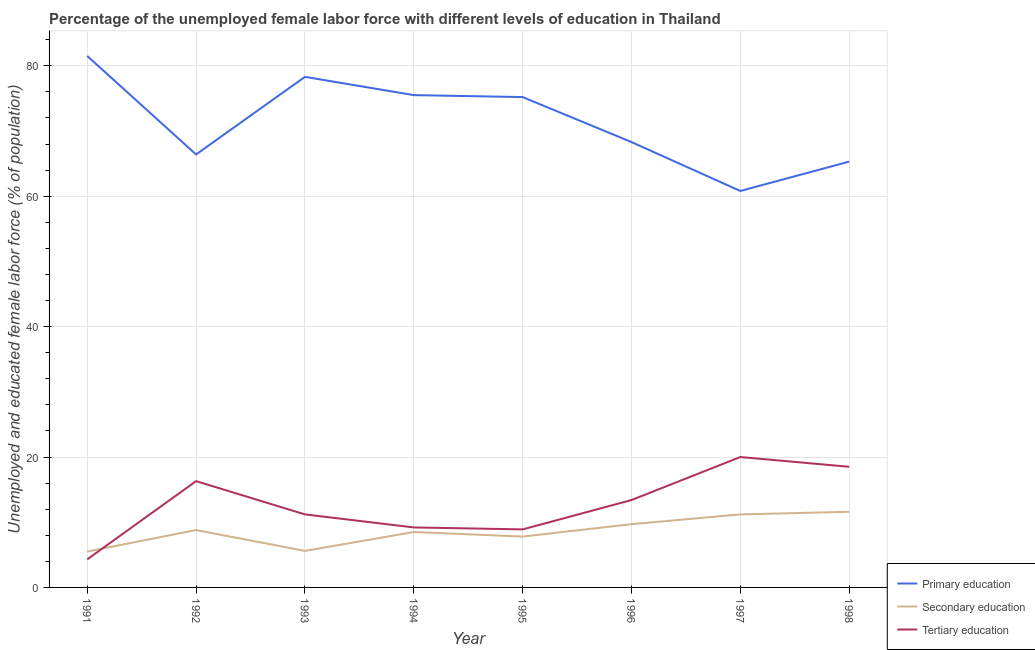How many different coloured lines are there?
Your answer should be very brief. 3. What is the percentage of female labor force who received secondary education in 1992?
Provide a succinct answer. 8.8. Across all years, what is the maximum percentage of female labor force who received secondary education?
Your answer should be very brief. 11.6. Across all years, what is the minimum percentage of female labor force who received secondary education?
Give a very brief answer. 5.5. In which year was the percentage of female labor force who received tertiary education minimum?
Offer a terse response. 1991. What is the total percentage of female labor force who received tertiary education in the graph?
Your answer should be compact. 101.8. What is the difference between the percentage of female labor force who received tertiary education in 1995 and that in 1996?
Ensure brevity in your answer.  -4.5. What is the difference between the percentage of female labor force who received secondary education in 1996 and the percentage of female labor force who received tertiary education in 1993?
Your answer should be compact. -1.5. What is the average percentage of female labor force who received secondary education per year?
Offer a terse response. 8.59. In the year 1997, what is the difference between the percentage of female labor force who received primary education and percentage of female labor force who received tertiary education?
Offer a terse response. 40.8. What is the ratio of the percentage of female labor force who received primary education in 1992 to that in 1998?
Your answer should be very brief. 1.02. Is the difference between the percentage of female labor force who received secondary education in 1991 and 1996 greater than the difference between the percentage of female labor force who received tertiary education in 1991 and 1996?
Your answer should be compact. Yes. What is the difference between the highest and the second highest percentage of female labor force who received primary education?
Make the answer very short. 3.2. What is the difference between the highest and the lowest percentage of female labor force who received primary education?
Offer a terse response. 20.7. In how many years, is the percentage of female labor force who received secondary education greater than the average percentage of female labor force who received secondary education taken over all years?
Keep it short and to the point. 4. Is the sum of the percentage of female labor force who received primary education in 1996 and 1997 greater than the maximum percentage of female labor force who received tertiary education across all years?
Provide a succinct answer. Yes. How many lines are there?
Make the answer very short. 3. What is the difference between two consecutive major ticks on the Y-axis?
Offer a very short reply. 20. Does the graph contain any zero values?
Provide a short and direct response. No. Does the graph contain grids?
Your answer should be very brief. Yes. What is the title of the graph?
Offer a terse response. Percentage of the unemployed female labor force with different levels of education in Thailand. What is the label or title of the X-axis?
Keep it short and to the point. Year. What is the label or title of the Y-axis?
Offer a very short reply. Unemployed and educated female labor force (% of population). What is the Unemployed and educated female labor force (% of population) in Primary education in 1991?
Offer a very short reply. 81.5. What is the Unemployed and educated female labor force (% of population) in Tertiary education in 1991?
Your answer should be very brief. 4.3. What is the Unemployed and educated female labor force (% of population) in Primary education in 1992?
Your answer should be compact. 66.4. What is the Unemployed and educated female labor force (% of population) in Secondary education in 1992?
Provide a short and direct response. 8.8. What is the Unemployed and educated female labor force (% of population) in Tertiary education in 1992?
Your response must be concise. 16.3. What is the Unemployed and educated female labor force (% of population) of Primary education in 1993?
Your answer should be very brief. 78.3. What is the Unemployed and educated female labor force (% of population) of Secondary education in 1993?
Your response must be concise. 5.6. What is the Unemployed and educated female labor force (% of population) in Tertiary education in 1993?
Ensure brevity in your answer.  11.2. What is the Unemployed and educated female labor force (% of population) of Primary education in 1994?
Your answer should be compact. 75.5. What is the Unemployed and educated female labor force (% of population) in Tertiary education in 1994?
Make the answer very short. 9.2. What is the Unemployed and educated female labor force (% of population) in Primary education in 1995?
Offer a terse response. 75.2. What is the Unemployed and educated female labor force (% of population) of Secondary education in 1995?
Provide a succinct answer. 7.8. What is the Unemployed and educated female labor force (% of population) of Tertiary education in 1995?
Your response must be concise. 8.9. What is the Unemployed and educated female labor force (% of population) of Primary education in 1996?
Offer a terse response. 68.3. What is the Unemployed and educated female labor force (% of population) of Secondary education in 1996?
Provide a short and direct response. 9.7. What is the Unemployed and educated female labor force (% of population) of Tertiary education in 1996?
Your response must be concise. 13.4. What is the Unemployed and educated female labor force (% of population) of Primary education in 1997?
Give a very brief answer. 60.8. What is the Unemployed and educated female labor force (% of population) in Secondary education in 1997?
Provide a succinct answer. 11.2. What is the Unemployed and educated female labor force (% of population) in Tertiary education in 1997?
Your answer should be compact. 20. What is the Unemployed and educated female labor force (% of population) of Primary education in 1998?
Give a very brief answer. 65.3. What is the Unemployed and educated female labor force (% of population) in Secondary education in 1998?
Ensure brevity in your answer.  11.6. Across all years, what is the maximum Unemployed and educated female labor force (% of population) of Primary education?
Offer a terse response. 81.5. Across all years, what is the maximum Unemployed and educated female labor force (% of population) in Secondary education?
Ensure brevity in your answer.  11.6. Across all years, what is the minimum Unemployed and educated female labor force (% of population) of Primary education?
Your response must be concise. 60.8. Across all years, what is the minimum Unemployed and educated female labor force (% of population) of Tertiary education?
Your answer should be very brief. 4.3. What is the total Unemployed and educated female labor force (% of population) of Primary education in the graph?
Ensure brevity in your answer.  571.3. What is the total Unemployed and educated female labor force (% of population) in Secondary education in the graph?
Offer a terse response. 68.7. What is the total Unemployed and educated female labor force (% of population) in Tertiary education in the graph?
Give a very brief answer. 101.8. What is the difference between the Unemployed and educated female labor force (% of population) in Primary education in 1991 and that in 1992?
Keep it short and to the point. 15.1. What is the difference between the Unemployed and educated female labor force (% of population) of Tertiary education in 1991 and that in 1992?
Keep it short and to the point. -12. What is the difference between the Unemployed and educated female labor force (% of population) of Secondary education in 1991 and that in 1993?
Give a very brief answer. -0.1. What is the difference between the Unemployed and educated female labor force (% of population) in Tertiary education in 1991 and that in 1993?
Make the answer very short. -6.9. What is the difference between the Unemployed and educated female labor force (% of population) of Primary education in 1991 and that in 1994?
Your response must be concise. 6. What is the difference between the Unemployed and educated female labor force (% of population) in Secondary education in 1991 and that in 1994?
Your response must be concise. -3. What is the difference between the Unemployed and educated female labor force (% of population) in Tertiary education in 1991 and that in 1995?
Offer a terse response. -4.6. What is the difference between the Unemployed and educated female labor force (% of population) of Tertiary education in 1991 and that in 1996?
Ensure brevity in your answer.  -9.1. What is the difference between the Unemployed and educated female labor force (% of population) of Primary education in 1991 and that in 1997?
Your response must be concise. 20.7. What is the difference between the Unemployed and educated female labor force (% of population) of Tertiary education in 1991 and that in 1997?
Make the answer very short. -15.7. What is the difference between the Unemployed and educated female labor force (% of population) in Tertiary education in 1991 and that in 1998?
Your response must be concise. -14.2. What is the difference between the Unemployed and educated female labor force (% of population) of Primary education in 1992 and that in 1993?
Provide a short and direct response. -11.9. What is the difference between the Unemployed and educated female labor force (% of population) in Primary education in 1992 and that in 1994?
Offer a terse response. -9.1. What is the difference between the Unemployed and educated female labor force (% of population) in Secondary education in 1992 and that in 1995?
Provide a short and direct response. 1. What is the difference between the Unemployed and educated female labor force (% of population) in Primary education in 1992 and that in 1996?
Give a very brief answer. -1.9. What is the difference between the Unemployed and educated female labor force (% of population) in Secondary education in 1992 and that in 1996?
Make the answer very short. -0.9. What is the difference between the Unemployed and educated female labor force (% of population) of Primary education in 1992 and that in 1997?
Offer a terse response. 5.6. What is the difference between the Unemployed and educated female labor force (% of population) of Primary education in 1992 and that in 1998?
Offer a very short reply. 1.1. What is the difference between the Unemployed and educated female labor force (% of population) of Secondary education in 1992 and that in 1998?
Make the answer very short. -2.8. What is the difference between the Unemployed and educated female labor force (% of population) in Tertiary education in 1992 and that in 1998?
Offer a terse response. -2.2. What is the difference between the Unemployed and educated female labor force (% of population) of Primary education in 1993 and that in 1994?
Offer a very short reply. 2.8. What is the difference between the Unemployed and educated female labor force (% of population) in Tertiary education in 1993 and that in 1994?
Ensure brevity in your answer.  2. What is the difference between the Unemployed and educated female labor force (% of population) of Primary education in 1993 and that in 1995?
Keep it short and to the point. 3.1. What is the difference between the Unemployed and educated female labor force (% of population) in Tertiary education in 1993 and that in 1995?
Offer a very short reply. 2.3. What is the difference between the Unemployed and educated female labor force (% of population) in Primary education in 1993 and that in 1996?
Your answer should be very brief. 10. What is the difference between the Unemployed and educated female labor force (% of population) of Secondary education in 1993 and that in 1996?
Provide a short and direct response. -4.1. What is the difference between the Unemployed and educated female labor force (% of population) of Tertiary education in 1993 and that in 1997?
Give a very brief answer. -8.8. What is the difference between the Unemployed and educated female labor force (% of population) in Secondary education in 1994 and that in 1995?
Provide a short and direct response. 0.7. What is the difference between the Unemployed and educated female labor force (% of population) of Primary education in 1994 and that in 1996?
Your answer should be very brief. 7.2. What is the difference between the Unemployed and educated female labor force (% of population) in Tertiary education in 1994 and that in 1996?
Your answer should be very brief. -4.2. What is the difference between the Unemployed and educated female labor force (% of population) of Secondary education in 1994 and that in 1997?
Make the answer very short. -2.7. What is the difference between the Unemployed and educated female labor force (% of population) in Tertiary education in 1994 and that in 1997?
Provide a short and direct response. -10.8. What is the difference between the Unemployed and educated female labor force (% of population) of Primary education in 1994 and that in 1998?
Provide a succinct answer. 10.2. What is the difference between the Unemployed and educated female labor force (% of population) in Secondary education in 1994 and that in 1998?
Give a very brief answer. -3.1. What is the difference between the Unemployed and educated female labor force (% of population) of Tertiary education in 1994 and that in 1998?
Provide a short and direct response. -9.3. What is the difference between the Unemployed and educated female labor force (% of population) of Tertiary education in 1995 and that in 1996?
Provide a succinct answer. -4.5. What is the difference between the Unemployed and educated female labor force (% of population) of Secondary education in 1995 and that in 1997?
Give a very brief answer. -3.4. What is the difference between the Unemployed and educated female labor force (% of population) of Tertiary education in 1995 and that in 1997?
Offer a very short reply. -11.1. What is the difference between the Unemployed and educated female labor force (% of population) of Tertiary education in 1995 and that in 1998?
Ensure brevity in your answer.  -9.6. What is the difference between the Unemployed and educated female labor force (% of population) of Primary education in 1996 and that in 1997?
Offer a very short reply. 7.5. What is the difference between the Unemployed and educated female labor force (% of population) of Secondary education in 1996 and that in 1997?
Your answer should be compact. -1.5. What is the difference between the Unemployed and educated female labor force (% of population) in Tertiary education in 1996 and that in 1998?
Offer a terse response. -5.1. What is the difference between the Unemployed and educated female labor force (% of population) of Primary education in 1997 and that in 1998?
Make the answer very short. -4.5. What is the difference between the Unemployed and educated female labor force (% of population) of Secondary education in 1997 and that in 1998?
Provide a succinct answer. -0.4. What is the difference between the Unemployed and educated female labor force (% of population) in Tertiary education in 1997 and that in 1998?
Your answer should be compact. 1.5. What is the difference between the Unemployed and educated female labor force (% of population) in Primary education in 1991 and the Unemployed and educated female labor force (% of population) in Secondary education in 1992?
Give a very brief answer. 72.7. What is the difference between the Unemployed and educated female labor force (% of population) in Primary education in 1991 and the Unemployed and educated female labor force (% of population) in Tertiary education in 1992?
Ensure brevity in your answer.  65.2. What is the difference between the Unemployed and educated female labor force (% of population) in Secondary education in 1991 and the Unemployed and educated female labor force (% of population) in Tertiary education in 1992?
Your answer should be compact. -10.8. What is the difference between the Unemployed and educated female labor force (% of population) of Primary education in 1991 and the Unemployed and educated female labor force (% of population) of Secondary education in 1993?
Ensure brevity in your answer.  75.9. What is the difference between the Unemployed and educated female labor force (% of population) in Primary education in 1991 and the Unemployed and educated female labor force (% of population) in Tertiary education in 1993?
Your answer should be very brief. 70.3. What is the difference between the Unemployed and educated female labor force (% of population) in Secondary education in 1991 and the Unemployed and educated female labor force (% of population) in Tertiary education in 1993?
Provide a succinct answer. -5.7. What is the difference between the Unemployed and educated female labor force (% of population) in Primary education in 1991 and the Unemployed and educated female labor force (% of population) in Secondary education in 1994?
Your answer should be very brief. 73. What is the difference between the Unemployed and educated female labor force (% of population) in Primary education in 1991 and the Unemployed and educated female labor force (% of population) in Tertiary education in 1994?
Your answer should be compact. 72.3. What is the difference between the Unemployed and educated female labor force (% of population) in Secondary education in 1991 and the Unemployed and educated female labor force (% of population) in Tertiary education in 1994?
Ensure brevity in your answer.  -3.7. What is the difference between the Unemployed and educated female labor force (% of population) in Primary education in 1991 and the Unemployed and educated female labor force (% of population) in Secondary education in 1995?
Give a very brief answer. 73.7. What is the difference between the Unemployed and educated female labor force (% of population) in Primary education in 1991 and the Unemployed and educated female labor force (% of population) in Tertiary education in 1995?
Provide a succinct answer. 72.6. What is the difference between the Unemployed and educated female labor force (% of population) of Primary education in 1991 and the Unemployed and educated female labor force (% of population) of Secondary education in 1996?
Give a very brief answer. 71.8. What is the difference between the Unemployed and educated female labor force (% of population) in Primary education in 1991 and the Unemployed and educated female labor force (% of population) in Tertiary education in 1996?
Your response must be concise. 68.1. What is the difference between the Unemployed and educated female labor force (% of population) in Secondary education in 1991 and the Unemployed and educated female labor force (% of population) in Tertiary education in 1996?
Keep it short and to the point. -7.9. What is the difference between the Unemployed and educated female labor force (% of population) in Primary education in 1991 and the Unemployed and educated female labor force (% of population) in Secondary education in 1997?
Offer a very short reply. 70.3. What is the difference between the Unemployed and educated female labor force (% of population) in Primary education in 1991 and the Unemployed and educated female labor force (% of population) in Tertiary education in 1997?
Ensure brevity in your answer.  61.5. What is the difference between the Unemployed and educated female labor force (% of population) of Primary education in 1991 and the Unemployed and educated female labor force (% of population) of Secondary education in 1998?
Your answer should be compact. 69.9. What is the difference between the Unemployed and educated female labor force (% of population) in Primary education in 1992 and the Unemployed and educated female labor force (% of population) in Secondary education in 1993?
Your response must be concise. 60.8. What is the difference between the Unemployed and educated female labor force (% of population) of Primary education in 1992 and the Unemployed and educated female labor force (% of population) of Tertiary education in 1993?
Make the answer very short. 55.2. What is the difference between the Unemployed and educated female labor force (% of population) in Secondary education in 1992 and the Unemployed and educated female labor force (% of population) in Tertiary education in 1993?
Make the answer very short. -2.4. What is the difference between the Unemployed and educated female labor force (% of population) in Primary education in 1992 and the Unemployed and educated female labor force (% of population) in Secondary education in 1994?
Offer a terse response. 57.9. What is the difference between the Unemployed and educated female labor force (% of population) of Primary education in 1992 and the Unemployed and educated female labor force (% of population) of Tertiary education in 1994?
Ensure brevity in your answer.  57.2. What is the difference between the Unemployed and educated female labor force (% of population) in Secondary education in 1992 and the Unemployed and educated female labor force (% of population) in Tertiary education in 1994?
Provide a succinct answer. -0.4. What is the difference between the Unemployed and educated female labor force (% of population) in Primary education in 1992 and the Unemployed and educated female labor force (% of population) in Secondary education in 1995?
Your answer should be compact. 58.6. What is the difference between the Unemployed and educated female labor force (% of population) in Primary education in 1992 and the Unemployed and educated female labor force (% of population) in Tertiary education in 1995?
Your response must be concise. 57.5. What is the difference between the Unemployed and educated female labor force (% of population) of Secondary education in 1992 and the Unemployed and educated female labor force (% of population) of Tertiary education in 1995?
Offer a terse response. -0.1. What is the difference between the Unemployed and educated female labor force (% of population) in Primary education in 1992 and the Unemployed and educated female labor force (% of population) in Secondary education in 1996?
Make the answer very short. 56.7. What is the difference between the Unemployed and educated female labor force (% of population) in Primary education in 1992 and the Unemployed and educated female labor force (% of population) in Tertiary education in 1996?
Your answer should be compact. 53. What is the difference between the Unemployed and educated female labor force (% of population) in Primary education in 1992 and the Unemployed and educated female labor force (% of population) in Secondary education in 1997?
Ensure brevity in your answer.  55.2. What is the difference between the Unemployed and educated female labor force (% of population) of Primary education in 1992 and the Unemployed and educated female labor force (% of population) of Tertiary education in 1997?
Make the answer very short. 46.4. What is the difference between the Unemployed and educated female labor force (% of population) of Primary education in 1992 and the Unemployed and educated female labor force (% of population) of Secondary education in 1998?
Offer a terse response. 54.8. What is the difference between the Unemployed and educated female labor force (% of population) in Primary education in 1992 and the Unemployed and educated female labor force (% of population) in Tertiary education in 1998?
Provide a short and direct response. 47.9. What is the difference between the Unemployed and educated female labor force (% of population) in Primary education in 1993 and the Unemployed and educated female labor force (% of population) in Secondary education in 1994?
Your answer should be very brief. 69.8. What is the difference between the Unemployed and educated female labor force (% of population) in Primary education in 1993 and the Unemployed and educated female labor force (% of population) in Tertiary education in 1994?
Your response must be concise. 69.1. What is the difference between the Unemployed and educated female labor force (% of population) in Secondary education in 1993 and the Unemployed and educated female labor force (% of population) in Tertiary education in 1994?
Offer a terse response. -3.6. What is the difference between the Unemployed and educated female labor force (% of population) in Primary education in 1993 and the Unemployed and educated female labor force (% of population) in Secondary education in 1995?
Keep it short and to the point. 70.5. What is the difference between the Unemployed and educated female labor force (% of population) of Primary education in 1993 and the Unemployed and educated female labor force (% of population) of Tertiary education in 1995?
Give a very brief answer. 69.4. What is the difference between the Unemployed and educated female labor force (% of population) in Primary education in 1993 and the Unemployed and educated female labor force (% of population) in Secondary education in 1996?
Your answer should be very brief. 68.6. What is the difference between the Unemployed and educated female labor force (% of population) in Primary education in 1993 and the Unemployed and educated female labor force (% of population) in Tertiary education in 1996?
Ensure brevity in your answer.  64.9. What is the difference between the Unemployed and educated female labor force (% of population) in Primary education in 1993 and the Unemployed and educated female labor force (% of population) in Secondary education in 1997?
Ensure brevity in your answer.  67.1. What is the difference between the Unemployed and educated female labor force (% of population) in Primary education in 1993 and the Unemployed and educated female labor force (% of population) in Tertiary education in 1997?
Your response must be concise. 58.3. What is the difference between the Unemployed and educated female labor force (% of population) of Secondary education in 1993 and the Unemployed and educated female labor force (% of population) of Tertiary education in 1997?
Provide a succinct answer. -14.4. What is the difference between the Unemployed and educated female labor force (% of population) in Primary education in 1993 and the Unemployed and educated female labor force (% of population) in Secondary education in 1998?
Your response must be concise. 66.7. What is the difference between the Unemployed and educated female labor force (% of population) in Primary education in 1993 and the Unemployed and educated female labor force (% of population) in Tertiary education in 1998?
Your answer should be very brief. 59.8. What is the difference between the Unemployed and educated female labor force (% of population) of Primary education in 1994 and the Unemployed and educated female labor force (% of population) of Secondary education in 1995?
Make the answer very short. 67.7. What is the difference between the Unemployed and educated female labor force (% of population) of Primary education in 1994 and the Unemployed and educated female labor force (% of population) of Tertiary education in 1995?
Offer a terse response. 66.6. What is the difference between the Unemployed and educated female labor force (% of population) in Secondary education in 1994 and the Unemployed and educated female labor force (% of population) in Tertiary education in 1995?
Make the answer very short. -0.4. What is the difference between the Unemployed and educated female labor force (% of population) in Primary education in 1994 and the Unemployed and educated female labor force (% of population) in Secondary education in 1996?
Offer a very short reply. 65.8. What is the difference between the Unemployed and educated female labor force (% of population) of Primary education in 1994 and the Unemployed and educated female labor force (% of population) of Tertiary education in 1996?
Keep it short and to the point. 62.1. What is the difference between the Unemployed and educated female labor force (% of population) of Secondary education in 1994 and the Unemployed and educated female labor force (% of population) of Tertiary education in 1996?
Your response must be concise. -4.9. What is the difference between the Unemployed and educated female labor force (% of population) of Primary education in 1994 and the Unemployed and educated female labor force (% of population) of Secondary education in 1997?
Your response must be concise. 64.3. What is the difference between the Unemployed and educated female labor force (% of population) in Primary education in 1994 and the Unemployed and educated female labor force (% of population) in Tertiary education in 1997?
Your answer should be compact. 55.5. What is the difference between the Unemployed and educated female labor force (% of population) of Primary education in 1994 and the Unemployed and educated female labor force (% of population) of Secondary education in 1998?
Provide a short and direct response. 63.9. What is the difference between the Unemployed and educated female labor force (% of population) in Primary education in 1994 and the Unemployed and educated female labor force (% of population) in Tertiary education in 1998?
Your answer should be very brief. 57. What is the difference between the Unemployed and educated female labor force (% of population) in Secondary education in 1994 and the Unemployed and educated female labor force (% of population) in Tertiary education in 1998?
Make the answer very short. -10. What is the difference between the Unemployed and educated female labor force (% of population) in Primary education in 1995 and the Unemployed and educated female labor force (% of population) in Secondary education in 1996?
Keep it short and to the point. 65.5. What is the difference between the Unemployed and educated female labor force (% of population) of Primary education in 1995 and the Unemployed and educated female labor force (% of population) of Tertiary education in 1996?
Keep it short and to the point. 61.8. What is the difference between the Unemployed and educated female labor force (% of population) of Primary education in 1995 and the Unemployed and educated female labor force (% of population) of Tertiary education in 1997?
Your answer should be compact. 55.2. What is the difference between the Unemployed and educated female labor force (% of population) of Primary education in 1995 and the Unemployed and educated female labor force (% of population) of Secondary education in 1998?
Provide a short and direct response. 63.6. What is the difference between the Unemployed and educated female labor force (% of population) in Primary education in 1995 and the Unemployed and educated female labor force (% of population) in Tertiary education in 1998?
Provide a succinct answer. 56.7. What is the difference between the Unemployed and educated female labor force (% of population) in Primary education in 1996 and the Unemployed and educated female labor force (% of population) in Secondary education in 1997?
Make the answer very short. 57.1. What is the difference between the Unemployed and educated female labor force (% of population) in Primary education in 1996 and the Unemployed and educated female labor force (% of population) in Tertiary education in 1997?
Your answer should be compact. 48.3. What is the difference between the Unemployed and educated female labor force (% of population) of Primary education in 1996 and the Unemployed and educated female labor force (% of population) of Secondary education in 1998?
Provide a short and direct response. 56.7. What is the difference between the Unemployed and educated female labor force (% of population) in Primary education in 1996 and the Unemployed and educated female labor force (% of population) in Tertiary education in 1998?
Provide a succinct answer. 49.8. What is the difference between the Unemployed and educated female labor force (% of population) of Primary education in 1997 and the Unemployed and educated female labor force (% of population) of Secondary education in 1998?
Your answer should be compact. 49.2. What is the difference between the Unemployed and educated female labor force (% of population) of Primary education in 1997 and the Unemployed and educated female labor force (% of population) of Tertiary education in 1998?
Your response must be concise. 42.3. What is the difference between the Unemployed and educated female labor force (% of population) in Secondary education in 1997 and the Unemployed and educated female labor force (% of population) in Tertiary education in 1998?
Keep it short and to the point. -7.3. What is the average Unemployed and educated female labor force (% of population) of Primary education per year?
Offer a very short reply. 71.41. What is the average Unemployed and educated female labor force (% of population) in Secondary education per year?
Ensure brevity in your answer.  8.59. What is the average Unemployed and educated female labor force (% of population) of Tertiary education per year?
Provide a short and direct response. 12.72. In the year 1991, what is the difference between the Unemployed and educated female labor force (% of population) in Primary education and Unemployed and educated female labor force (% of population) in Tertiary education?
Your answer should be compact. 77.2. In the year 1992, what is the difference between the Unemployed and educated female labor force (% of population) in Primary education and Unemployed and educated female labor force (% of population) in Secondary education?
Ensure brevity in your answer.  57.6. In the year 1992, what is the difference between the Unemployed and educated female labor force (% of population) in Primary education and Unemployed and educated female labor force (% of population) in Tertiary education?
Your answer should be compact. 50.1. In the year 1992, what is the difference between the Unemployed and educated female labor force (% of population) in Secondary education and Unemployed and educated female labor force (% of population) in Tertiary education?
Offer a very short reply. -7.5. In the year 1993, what is the difference between the Unemployed and educated female labor force (% of population) of Primary education and Unemployed and educated female labor force (% of population) of Secondary education?
Keep it short and to the point. 72.7. In the year 1993, what is the difference between the Unemployed and educated female labor force (% of population) of Primary education and Unemployed and educated female labor force (% of population) of Tertiary education?
Provide a short and direct response. 67.1. In the year 1994, what is the difference between the Unemployed and educated female labor force (% of population) of Primary education and Unemployed and educated female labor force (% of population) of Tertiary education?
Provide a succinct answer. 66.3. In the year 1994, what is the difference between the Unemployed and educated female labor force (% of population) of Secondary education and Unemployed and educated female labor force (% of population) of Tertiary education?
Provide a short and direct response. -0.7. In the year 1995, what is the difference between the Unemployed and educated female labor force (% of population) of Primary education and Unemployed and educated female labor force (% of population) of Secondary education?
Keep it short and to the point. 67.4. In the year 1995, what is the difference between the Unemployed and educated female labor force (% of population) in Primary education and Unemployed and educated female labor force (% of population) in Tertiary education?
Your answer should be very brief. 66.3. In the year 1995, what is the difference between the Unemployed and educated female labor force (% of population) of Secondary education and Unemployed and educated female labor force (% of population) of Tertiary education?
Offer a terse response. -1.1. In the year 1996, what is the difference between the Unemployed and educated female labor force (% of population) of Primary education and Unemployed and educated female labor force (% of population) of Secondary education?
Provide a short and direct response. 58.6. In the year 1996, what is the difference between the Unemployed and educated female labor force (% of population) of Primary education and Unemployed and educated female labor force (% of population) of Tertiary education?
Offer a very short reply. 54.9. In the year 1997, what is the difference between the Unemployed and educated female labor force (% of population) of Primary education and Unemployed and educated female labor force (% of population) of Secondary education?
Give a very brief answer. 49.6. In the year 1997, what is the difference between the Unemployed and educated female labor force (% of population) in Primary education and Unemployed and educated female labor force (% of population) in Tertiary education?
Your answer should be compact. 40.8. In the year 1997, what is the difference between the Unemployed and educated female labor force (% of population) in Secondary education and Unemployed and educated female labor force (% of population) in Tertiary education?
Your answer should be very brief. -8.8. In the year 1998, what is the difference between the Unemployed and educated female labor force (% of population) in Primary education and Unemployed and educated female labor force (% of population) in Secondary education?
Ensure brevity in your answer.  53.7. In the year 1998, what is the difference between the Unemployed and educated female labor force (% of population) of Primary education and Unemployed and educated female labor force (% of population) of Tertiary education?
Your answer should be very brief. 46.8. What is the ratio of the Unemployed and educated female labor force (% of population) of Primary education in 1991 to that in 1992?
Give a very brief answer. 1.23. What is the ratio of the Unemployed and educated female labor force (% of population) in Tertiary education in 1991 to that in 1992?
Make the answer very short. 0.26. What is the ratio of the Unemployed and educated female labor force (% of population) of Primary education in 1991 to that in 1993?
Make the answer very short. 1.04. What is the ratio of the Unemployed and educated female labor force (% of population) of Secondary education in 1991 to that in 1993?
Give a very brief answer. 0.98. What is the ratio of the Unemployed and educated female labor force (% of population) in Tertiary education in 1991 to that in 1993?
Provide a short and direct response. 0.38. What is the ratio of the Unemployed and educated female labor force (% of population) of Primary education in 1991 to that in 1994?
Your response must be concise. 1.08. What is the ratio of the Unemployed and educated female labor force (% of population) in Secondary education in 1991 to that in 1994?
Offer a terse response. 0.65. What is the ratio of the Unemployed and educated female labor force (% of population) in Tertiary education in 1991 to that in 1994?
Keep it short and to the point. 0.47. What is the ratio of the Unemployed and educated female labor force (% of population) in Primary education in 1991 to that in 1995?
Your response must be concise. 1.08. What is the ratio of the Unemployed and educated female labor force (% of population) of Secondary education in 1991 to that in 1995?
Provide a short and direct response. 0.71. What is the ratio of the Unemployed and educated female labor force (% of population) in Tertiary education in 1991 to that in 1995?
Provide a succinct answer. 0.48. What is the ratio of the Unemployed and educated female labor force (% of population) of Primary education in 1991 to that in 1996?
Offer a very short reply. 1.19. What is the ratio of the Unemployed and educated female labor force (% of population) in Secondary education in 1991 to that in 1996?
Your response must be concise. 0.57. What is the ratio of the Unemployed and educated female labor force (% of population) in Tertiary education in 1991 to that in 1996?
Give a very brief answer. 0.32. What is the ratio of the Unemployed and educated female labor force (% of population) of Primary education in 1991 to that in 1997?
Your response must be concise. 1.34. What is the ratio of the Unemployed and educated female labor force (% of population) in Secondary education in 1991 to that in 1997?
Offer a terse response. 0.49. What is the ratio of the Unemployed and educated female labor force (% of population) in Tertiary education in 1991 to that in 1997?
Keep it short and to the point. 0.21. What is the ratio of the Unemployed and educated female labor force (% of population) of Primary education in 1991 to that in 1998?
Keep it short and to the point. 1.25. What is the ratio of the Unemployed and educated female labor force (% of population) in Secondary education in 1991 to that in 1998?
Provide a succinct answer. 0.47. What is the ratio of the Unemployed and educated female labor force (% of population) in Tertiary education in 1991 to that in 1998?
Your answer should be compact. 0.23. What is the ratio of the Unemployed and educated female labor force (% of population) in Primary education in 1992 to that in 1993?
Keep it short and to the point. 0.85. What is the ratio of the Unemployed and educated female labor force (% of population) in Secondary education in 1992 to that in 1993?
Provide a short and direct response. 1.57. What is the ratio of the Unemployed and educated female labor force (% of population) of Tertiary education in 1992 to that in 1993?
Keep it short and to the point. 1.46. What is the ratio of the Unemployed and educated female labor force (% of population) in Primary education in 1992 to that in 1994?
Make the answer very short. 0.88. What is the ratio of the Unemployed and educated female labor force (% of population) of Secondary education in 1992 to that in 1994?
Give a very brief answer. 1.04. What is the ratio of the Unemployed and educated female labor force (% of population) in Tertiary education in 1992 to that in 1994?
Offer a very short reply. 1.77. What is the ratio of the Unemployed and educated female labor force (% of population) in Primary education in 1992 to that in 1995?
Your response must be concise. 0.88. What is the ratio of the Unemployed and educated female labor force (% of population) in Secondary education in 1992 to that in 1995?
Offer a terse response. 1.13. What is the ratio of the Unemployed and educated female labor force (% of population) in Tertiary education in 1992 to that in 1995?
Offer a very short reply. 1.83. What is the ratio of the Unemployed and educated female labor force (% of population) of Primary education in 1992 to that in 1996?
Your answer should be very brief. 0.97. What is the ratio of the Unemployed and educated female labor force (% of population) of Secondary education in 1992 to that in 1996?
Your response must be concise. 0.91. What is the ratio of the Unemployed and educated female labor force (% of population) in Tertiary education in 1992 to that in 1996?
Ensure brevity in your answer.  1.22. What is the ratio of the Unemployed and educated female labor force (% of population) of Primary education in 1992 to that in 1997?
Keep it short and to the point. 1.09. What is the ratio of the Unemployed and educated female labor force (% of population) of Secondary education in 1992 to that in 1997?
Your answer should be compact. 0.79. What is the ratio of the Unemployed and educated female labor force (% of population) in Tertiary education in 1992 to that in 1997?
Offer a terse response. 0.81. What is the ratio of the Unemployed and educated female labor force (% of population) in Primary education in 1992 to that in 1998?
Give a very brief answer. 1.02. What is the ratio of the Unemployed and educated female labor force (% of population) in Secondary education in 1992 to that in 1998?
Make the answer very short. 0.76. What is the ratio of the Unemployed and educated female labor force (% of population) of Tertiary education in 1992 to that in 1998?
Offer a very short reply. 0.88. What is the ratio of the Unemployed and educated female labor force (% of population) in Primary education in 1993 to that in 1994?
Your answer should be very brief. 1.04. What is the ratio of the Unemployed and educated female labor force (% of population) of Secondary education in 1993 to that in 1994?
Offer a terse response. 0.66. What is the ratio of the Unemployed and educated female labor force (% of population) of Tertiary education in 1993 to that in 1994?
Offer a terse response. 1.22. What is the ratio of the Unemployed and educated female labor force (% of population) of Primary education in 1993 to that in 1995?
Offer a very short reply. 1.04. What is the ratio of the Unemployed and educated female labor force (% of population) of Secondary education in 1993 to that in 1995?
Your answer should be very brief. 0.72. What is the ratio of the Unemployed and educated female labor force (% of population) in Tertiary education in 1993 to that in 1995?
Offer a very short reply. 1.26. What is the ratio of the Unemployed and educated female labor force (% of population) in Primary education in 1993 to that in 1996?
Offer a terse response. 1.15. What is the ratio of the Unemployed and educated female labor force (% of population) of Secondary education in 1993 to that in 1996?
Ensure brevity in your answer.  0.58. What is the ratio of the Unemployed and educated female labor force (% of population) in Tertiary education in 1993 to that in 1996?
Give a very brief answer. 0.84. What is the ratio of the Unemployed and educated female labor force (% of population) of Primary education in 1993 to that in 1997?
Make the answer very short. 1.29. What is the ratio of the Unemployed and educated female labor force (% of population) of Secondary education in 1993 to that in 1997?
Your response must be concise. 0.5. What is the ratio of the Unemployed and educated female labor force (% of population) in Tertiary education in 1993 to that in 1997?
Provide a short and direct response. 0.56. What is the ratio of the Unemployed and educated female labor force (% of population) of Primary education in 1993 to that in 1998?
Provide a short and direct response. 1.2. What is the ratio of the Unemployed and educated female labor force (% of population) in Secondary education in 1993 to that in 1998?
Your response must be concise. 0.48. What is the ratio of the Unemployed and educated female labor force (% of population) of Tertiary education in 1993 to that in 1998?
Provide a short and direct response. 0.61. What is the ratio of the Unemployed and educated female labor force (% of population) of Primary education in 1994 to that in 1995?
Make the answer very short. 1. What is the ratio of the Unemployed and educated female labor force (% of population) of Secondary education in 1994 to that in 1995?
Give a very brief answer. 1.09. What is the ratio of the Unemployed and educated female labor force (% of population) of Tertiary education in 1994 to that in 1995?
Offer a very short reply. 1.03. What is the ratio of the Unemployed and educated female labor force (% of population) in Primary education in 1994 to that in 1996?
Provide a short and direct response. 1.11. What is the ratio of the Unemployed and educated female labor force (% of population) of Secondary education in 1994 to that in 1996?
Your answer should be very brief. 0.88. What is the ratio of the Unemployed and educated female labor force (% of population) of Tertiary education in 1994 to that in 1996?
Provide a short and direct response. 0.69. What is the ratio of the Unemployed and educated female labor force (% of population) of Primary education in 1994 to that in 1997?
Ensure brevity in your answer.  1.24. What is the ratio of the Unemployed and educated female labor force (% of population) in Secondary education in 1994 to that in 1997?
Provide a succinct answer. 0.76. What is the ratio of the Unemployed and educated female labor force (% of population) in Tertiary education in 1994 to that in 1997?
Offer a terse response. 0.46. What is the ratio of the Unemployed and educated female labor force (% of population) in Primary education in 1994 to that in 1998?
Make the answer very short. 1.16. What is the ratio of the Unemployed and educated female labor force (% of population) of Secondary education in 1994 to that in 1998?
Offer a terse response. 0.73. What is the ratio of the Unemployed and educated female labor force (% of population) of Tertiary education in 1994 to that in 1998?
Your answer should be compact. 0.5. What is the ratio of the Unemployed and educated female labor force (% of population) in Primary education in 1995 to that in 1996?
Your response must be concise. 1.1. What is the ratio of the Unemployed and educated female labor force (% of population) of Secondary education in 1995 to that in 1996?
Give a very brief answer. 0.8. What is the ratio of the Unemployed and educated female labor force (% of population) of Tertiary education in 1995 to that in 1996?
Provide a succinct answer. 0.66. What is the ratio of the Unemployed and educated female labor force (% of population) in Primary education in 1995 to that in 1997?
Provide a succinct answer. 1.24. What is the ratio of the Unemployed and educated female labor force (% of population) in Secondary education in 1995 to that in 1997?
Provide a succinct answer. 0.7. What is the ratio of the Unemployed and educated female labor force (% of population) in Tertiary education in 1995 to that in 1997?
Keep it short and to the point. 0.45. What is the ratio of the Unemployed and educated female labor force (% of population) of Primary education in 1995 to that in 1998?
Give a very brief answer. 1.15. What is the ratio of the Unemployed and educated female labor force (% of population) of Secondary education in 1995 to that in 1998?
Your answer should be very brief. 0.67. What is the ratio of the Unemployed and educated female labor force (% of population) in Tertiary education in 1995 to that in 1998?
Give a very brief answer. 0.48. What is the ratio of the Unemployed and educated female labor force (% of population) of Primary education in 1996 to that in 1997?
Give a very brief answer. 1.12. What is the ratio of the Unemployed and educated female labor force (% of population) of Secondary education in 1996 to that in 1997?
Your answer should be compact. 0.87. What is the ratio of the Unemployed and educated female labor force (% of population) of Tertiary education in 1996 to that in 1997?
Offer a terse response. 0.67. What is the ratio of the Unemployed and educated female labor force (% of population) of Primary education in 1996 to that in 1998?
Provide a succinct answer. 1.05. What is the ratio of the Unemployed and educated female labor force (% of population) in Secondary education in 1996 to that in 1998?
Offer a terse response. 0.84. What is the ratio of the Unemployed and educated female labor force (% of population) in Tertiary education in 1996 to that in 1998?
Provide a succinct answer. 0.72. What is the ratio of the Unemployed and educated female labor force (% of population) in Primary education in 1997 to that in 1998?
Give a very brief answer. 0.93. What is the ratio of the Unemployed and educated female labor force (% of population) in Secondary education in 1997 to that in 1998?
Your answer should be compact. 0.97. What is the ratio of the Unemployed and educated female labor force (% of population) in Tertiary education in 1997 to that in 1998?
Offer a very short reply. 1.08. What is the difference between the highest and the second highest Unemployed and educated female labor force (% of population) of Primary education?
Your response must be concise. 3.2. What is the difference between the highest and the second highest Unemployed and educated female labor force (% of population) of Secondary education?
Offer a very short reply. 0.4. What is the difference between the highest and the lowest Unemployed and educated female labor force (% of population) in Primary education?
Your answer should be very brief. 20.7. What is the difference between the highest and the lowest Unemployed and educated female labor force (% of population) of Secondary education?
Your response must be concise. 6.1. 